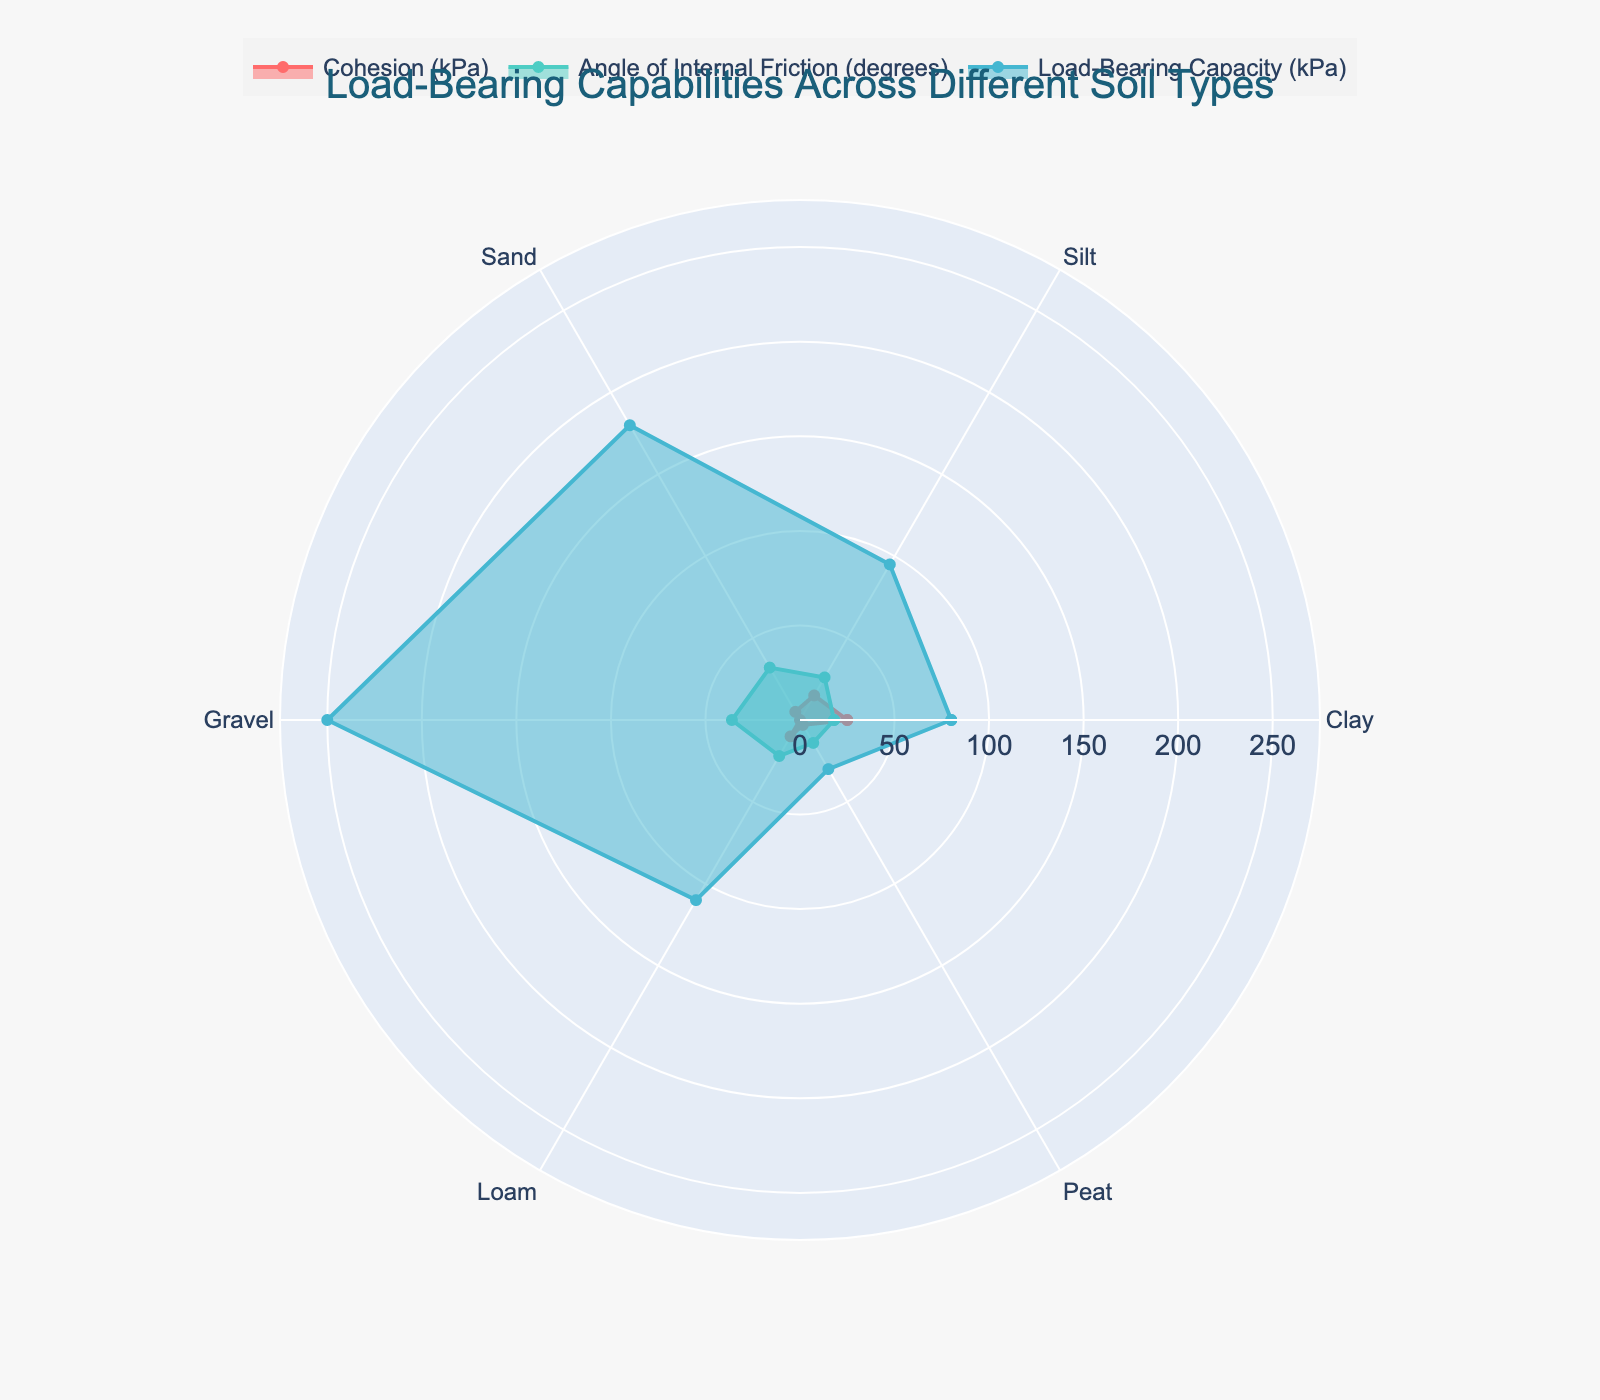What is the title of the radar chart? The title of the radar chart can be found at the top center of the chart.
Answer: Load-Bearing Capabilities Across Different Soil Types Which soil type has the highest load-bearing capacity? By looking at the load-bearing capacity trace, identify the data point with the maximum radial length.
Answer: Gravel What is the cohesion value for Clay? Locate the Clay data point on the cohesion trace and read the corresponding radial value.
Answer: 25 kPa How many different soil types are displayed on the radar chart? Count the number of unique categories listed around the circumference of the chart.
Answer: 6 What is the difference in load-bearing capacity between Sand and Peat? Find the load-bearing capacities for Sand and Peat on the respective trace, then subtract the Peat value from the Sand value (180 - 30).
Answer: 150 kPa Which soil type has the lowest angle of internal friction? By examining the angle of internal friction trace, identify the data point with the smallest radial length.
Answer: Peat Compare the cohesion of Gravel and Loam. Which one is higher? Locate the cohesion values for Gravel and Loam on the respective trace and compare their radial lengths.
Answer: Loam What is the average angle of internal friction across all soil types? Sum the angles of internal friction for all soil types and divide by the number of soil types (18 + 26 + 32 + 36 + 22 + 14) / 6.
Answer: 24.67 degrees Which soil type has the highest cohesion, and what is the value? Review the cohesion trace and locate the data point with the maximum radial length, then read the corresponding value.
Answer: Clay, 25 kPa How does the load-bearing capacity of Silt compare to that of Clay? Compare the radial lengths of Silt and Clay on the load-bearing capacity trace.
Answer: Silt has a higher load-bearing capacity than Clay 